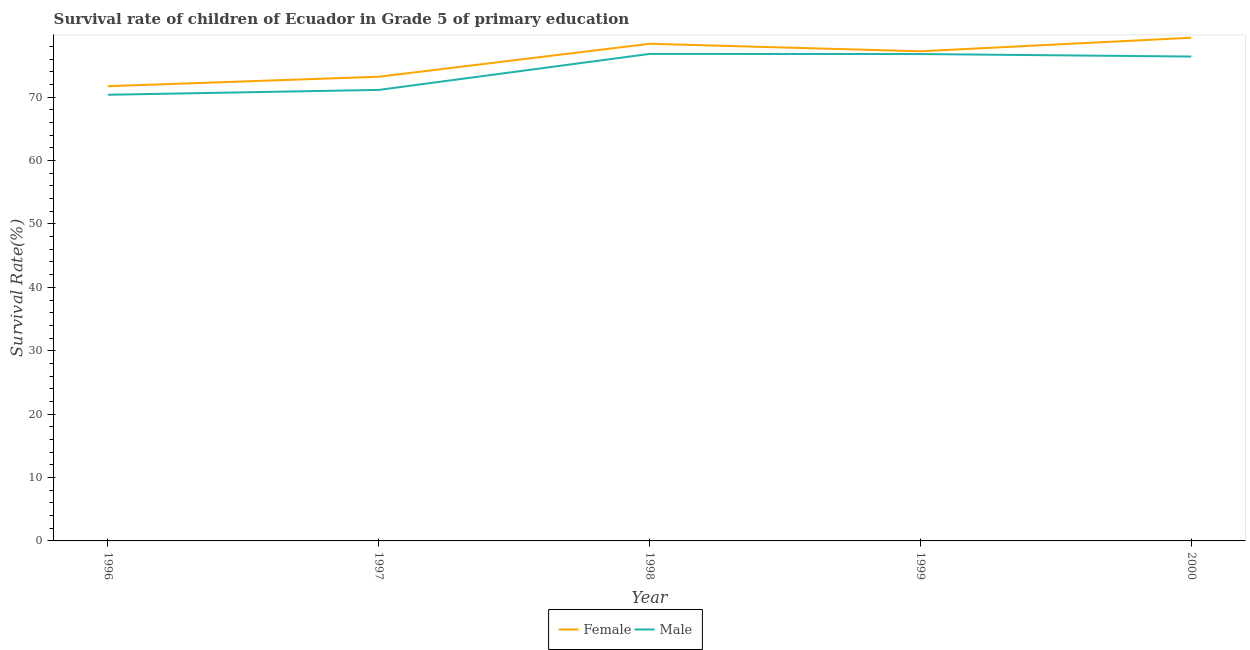How many different coloured lines are there?
Your answer should be compact. 2. Is the number of lines equal to the number of legend labels?
Your response must be concise. Yes. What is the survival rate of male students in primary education in 1998?
Provide a short and direct response. 76.82. Across all years, what is the maximum survival rate of female students in primary education?
Ensure brevity in your answer.  79.37. Across all years, what is the minimum survival rate of male students in primary education?
Your answer should be very brief. 70.38. What is the total survival rate of female students in primary education in the graph?
Keep it short and to the point. 379.98. What is the difference between the survival rate of female students in primary education in 1997 and that in 1998?
Provide a short and direct response. -5.2. What is the difference between the survival rate of male students in primary education in 2000 and the survival rate of female students in primary education in 1999?
Offer a terse response. -0.83. What is the average survival rate of male students in primary education per year?
Give a very brief answer. 74.31. In the year 1998, what is the difference between the survival rate of female students in primary education and survival rate of male students in primary education?
Offer a terse response. 1.6. In how many years, is the survival rate of male students in primary education greater than 6 %?
Offer a terse response. 5. What is the ratio of the survival rate of female students in primary education in 1996 to that in 1999?
Make the answer very short. 0.93. Is the difference between the survival rate of male students in primary education in 1996 and 1997 greater than the difference between the survival rate of female students in primary education in 1996 and 1997?
Your answer should be very brief. Yes. What is the difference between the highest and the second highest survival rate of female students in primary education?
Offer a very short reply. 0.95. What is the difference between the highest and the lowest survival rate of female students in primary education?
Your answer should be compact. 7.64. Does the survival rate of male students in primary education monotonically increase over the years?
Ensure brevity in your answer.  No. How many years are there in the graph?
Your answer should be very brief. 5. Does the graph contain any zero values?
Make the answer very short. No. Does the graph contain grids?
Ensure brevity in your answer.  No. Where does the legend appear in the graph?
Your answer should be very brief. Bottom center. How many legend labels are there?
Offer a terse response. 2. How are the legend labels stacked?
Your answer should be compact. Horizontal. What is the title of the graph?
Your response must be concise. Survival rate of children of Ecuador in Grade 5 of primary education. What is the label or title of the Y-axis?
Make the answer very short. Survival Rate(%). What is the Survival Rate(%) of Female in 1996?
Keep it short and to the point. 71.73. What is the Survival Rate(%) in Male in 1996?
Your answer should be compact. 70.38. What is the Survival Rate(%) in Female in 1997?
Your answer should be compact. 73.22. What is the Survival Rate(%) of Male in 1997?
Your answer should be compact. 71.14. What is the Survival Rate(%) in Female in 1998?
Give a very brief answer. 78.42. What is the Survival Rate(%) in Male in 1998?
Provide a succinct answer. 76.82. What is the Survival Rate(%) in Female in 1999?
Make the answer very short. 77.24. What is the Survival Rate(%) of Male in 1999?
Offer a terse response. 76.8. What is the Survival Rate(%) of Female in 2000?
Your response must be concise. 79.37. What is the Survival Rate(%) of Male in 2000?
Your answer should be compact. 76.4. Across all years, what is the maximum Survival Rate(%) of Female?
Give a very brief answer. 79.37. Across all years, what is the maximum Survival Rate(%) of Male?
Keep it short and to the point. 76.82. Across all years, what is the minimum Survival Rate(%) in Female?
Offer a very short reply. 71.73. Across all years, what is the minimum Survival Rate(%) in Male?
Offer a terse response. 70.38. What is the total Survival Rate(%) of Female in the graph?
Provide a short and direct response. 379.98. What is the total Survival Rate(%) in Male in the graph?
Offer a very short reply. 371.55. What is the difference between the Survival Rate(%) of Female in 1996 and that in 1997?
Make the answer very short. -1.49. What is the difference between the Survival Rate(%) in Male in 1996 and that in 1997?
Provide a short and direct response. -0.77. What is the difference between the Survival Rate(%) of Female in 1996 and that in 1998?
Offer a very short reply. -6.69. What is the difference between the Survival Rate(%) in Male in 1996 and that in 1998?
Give a very brief answer. -6.45. What is the difference between the Survival Rate(%) in Female in 1996 and that in 1999?
Offer a very short reply. -5.51. What is the difference between the Survival Rate(%) of Male in 1996 and that in 1999?
Provide a short and direct response. -6.42. What is the difference between the Survival Rate(%) in Female in 1996 and that in 2000?
Make the answer very short. -7.64. What is the difference between the Survival Rate(%) of Male in 1996 and that in 2000?
Ensure brevity in your answer.  -6.03. What is the difference between the Survival Rate(%) of Female in 1997 and that in 1998?
Provide a short and direct response. -5.2. What is the difference between the Survival Rate(%) of Male in 1997 and that in 1998?
Keep it short and to the point. -5.68. What is the difference between the Survival Rate(%) of Female in 1997 and that in 1999?
Your response must be concise. -4.01. What is the difference between the Survival Rate(%) of Male in 1997 and that in 1999?
Make the answer very short. -5.66. What is the difference between the Survival Rate(%) in Female in 1997 and that in 2000?
Your response must be concise. -6.15. What is the difference between the Survival Rate(%) of Male in 1997 and that in 2000?
Your answer should be compact. -5.26. What is the difference between the Survival Rate(%) in Female in 1998 and that in 1999?
Keep it short and to the point. 1.18. What is the difference between the Survival Rate(%) of Male in 1998 and that in 1999?
Make the answer very short. 0.02. What is the difference between the Survival Rate(%) in Female in 1998 and that in 2000?
Offer a very short reply. -0.95. What is the difference between the Survival Rate(%) in Male in 1998 and that in 2000?
Make the answer very short. 0.42. What is the difference between the Survival Rate(%) of Female in 1999 and that in 2000?
Ensure brevity in your answer.  -2.14. What is the difference between the Survival Rate(%) of Male in 1999 and that in 2000?
Your answer should be very brief. 0.39. What is the difference between the Survival Rate(%) in Female in 1996 and the Survival Rate(%) in Male in 1997?
Make the answer very short. 0.59. What is the difference between the Survival Rate(%) of Female in 1996 and the Survival Rate(%) of Male in 1998?
Your answer should be compact. -5.09. What is the difference between the Survival Rate(%) of Female in 1996 and the Survival Rate(%) of Male in 1999?
Make the answer very short. -5.07. What is the difference between the Survival Rate(%) in Female in 1996 and the Survival Rate(%) in Male in 2000?
Give a very brief answer. -4.67. What is the difference between the Survival Rate(%) of Female in 1997 and the Survival Rate(%) of Male in 1998?
Give a very brief answer. -3.6. What is the difference between the Survival Rate(%) of Female in 1997 and the Survival Rate(%) of Male in 1999?
Your answer should be very brief. -3.58. What is the difference between the Survival Rate(%) of Female in 1997 and the Survival Rate(%) of Male in 2000?
Provide a short and direct response. -3.18. What is the difference between the Survival Rate(%) in Female in 1998 and the Survival Rate(%) in Male in 1999?
Ensure brevity in your answer.  1.62. What is the difference between the Survival Rate(%) of Female in 1998 and the Survival Rate(%) of Male in 2000?
Provide a short and direct response. 2.01. What is the difference between the Survival Rate(%) in Female in 1999 and the Survival Rate(%) in Male in 2000?
Your answer should be very brief. 0.83. What is the average Survival Rate(%) in Female per year?
Ensure brevity in your answer.  76. What is the average Survival Rate(%) in Male per year?
Offer a very short reply. 74.31. In the year 1996, what is the difference between the Survival Rate(%) in Female and Survival Rate(%) in Male?
Make the answer very short. 1.35. In the year 1997, what is the difference between the Survival Rate(%) of Female and Survival Rate(%) of Male?
Keep it short and to the point. 2.08. In the year 1998, what is the difference between the Survival Rate(%) of Female and Survival Rate(%) of Male?
Ensure brevity in your answer.  1.6. In the year 1999, what is the difference between the Survival Rate(%) of Female and Survival Rate(%) of Male?
Provide a short and direct response. 0.44. In the year 2000, what is the difference between the Survival Rate(%) in Female and Survival Rate(%) in Male?
Your answer should be compact. 2.97. What is the ratio of the Survival Rate(%) of Female in 1996 to that in 1997?
Ensure brevity in your answer.  0.98. What is the ratio of the Survival Rate(%) of Female in 1996 to that in 1998?
Your answer should be compact. 0.91. What is the ratio of the Survival Rate(%) in Male in 1996 to that in 1998?
Your response must be concise. 0.92. What is the ratio of the Survival Rate(%) of Female in 1996 to that in 1999?
Make the answer very short. 0.93. What is the ratio of the Survival Rate(%) in Male in 1996 to that in 1999?
Provide a short and direct response. 0.92. What is the ratio of the Survival Rate(%) in Female in 1996 to that in 2000?
Your response must be concise. 0.9. What is the ratio of the Survival Rate(%) of Male in 1996 to that in 2000?
Offer a very short reply. 0.92. What is the ratio of the Survival Rate(%) in Female in 1997 to that in 1998?
Make the answer very short. 0.93. What is the ratio of the Survival Rate(%) in Male in 1997 to that in 1998?
Your answer should be compact. 0.93. What is the ratio of the Survival Rate(%) of Female in 1997 to that in 1999?
Ensure brevity in your answer.  0.95. What is the ratio of the Survival Rate(%) in Male in 1997 to that in 1999?
Ensure brevity in your answer.  0.93. What is the ratio of the Survival Rate(%) of Female in 1997 to that in 2000?
Offer a very short reply. 0.92. What is the ratio of the Survival Rate(%) in Male in 1997 to that in 2000?
Give a very brief answer. 0.93. What is the ratio of the Survival Rate(%) of Female in 1998 to that in 1999?
Provide a succinct answer. 1.02. What is the ratio of the Survival Rate(%) of Male in 1998 to that in 1999?
Keep it short and to the point. 1. What is the ratio of the Survival Rate(%) in Male in 1998 to that in 2000?
Make the answer very short. 1.01. What is the ratio of the Survival Rate(%) in Female in 1999 to that in 2000?
Give a very brief answer. 0.97. What is the difference between the highest and the second highest Survival Rate(%) of Female?
Ensure brevity in your answer.  0.95. What is the difference between the highest and the second highest Survival Rate(%) of Male?
Your answer should be compact. 0.02. What is the difference between the highest and the lowest Survival Rate(%) in Female?
Your response must be concise. 7.64. What is the difference between the highest and the lowest Survival Rate(%) in Male?
Your response must be concise. 6.45. 